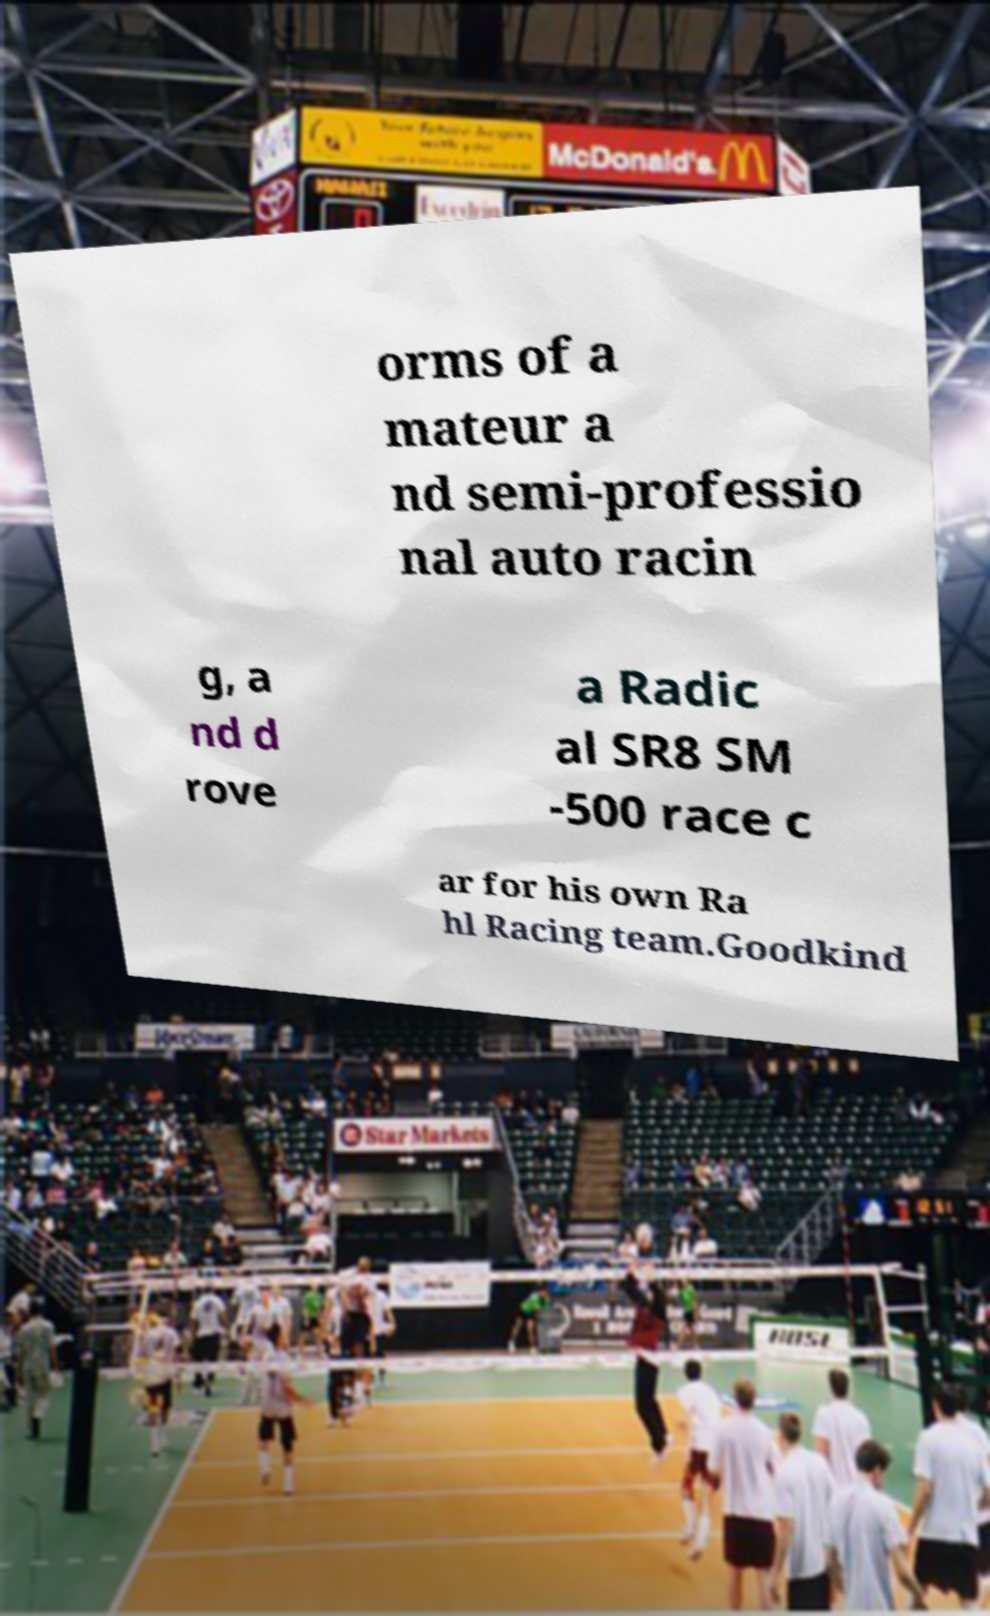Can you accurately transcribe the text from the provided image for me? orms of a mateur a nd semi-professio nal auto racin g, a nd d rove a Radic al SR8 SM -500 race c ar for his own Ra hl Racing team.Goodkind 